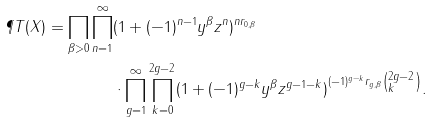Convert formula to latex. <formula><loc_0><loc_0><loc_500><loc_500>\P T ( X ) = \prod _ { \beta > 0 } \prod _ { n = 1 } ^ { \infty } & ( 1 + ( - 1 ) ^ { n - 1 } y ^ { \beta } z ^ { n } ) ^ { n r _ { 0 , \beta } } \\ & \cdot \prod _ { g = 1 } ^ { \infty } \prod _ { k = 0 } ^ { 2 g - 2 } ( 1 + ( - 1 ) ^ { g - k } y ^ { \beta } z ^ { g - 1 - k } ) ^ { ( - 1 ) ^ { g - k } r _ { g , \beta } \left ( \begin{subarray} { c } 2 g - 2 \\ k \end{subarray} \right ) } .</formula> 